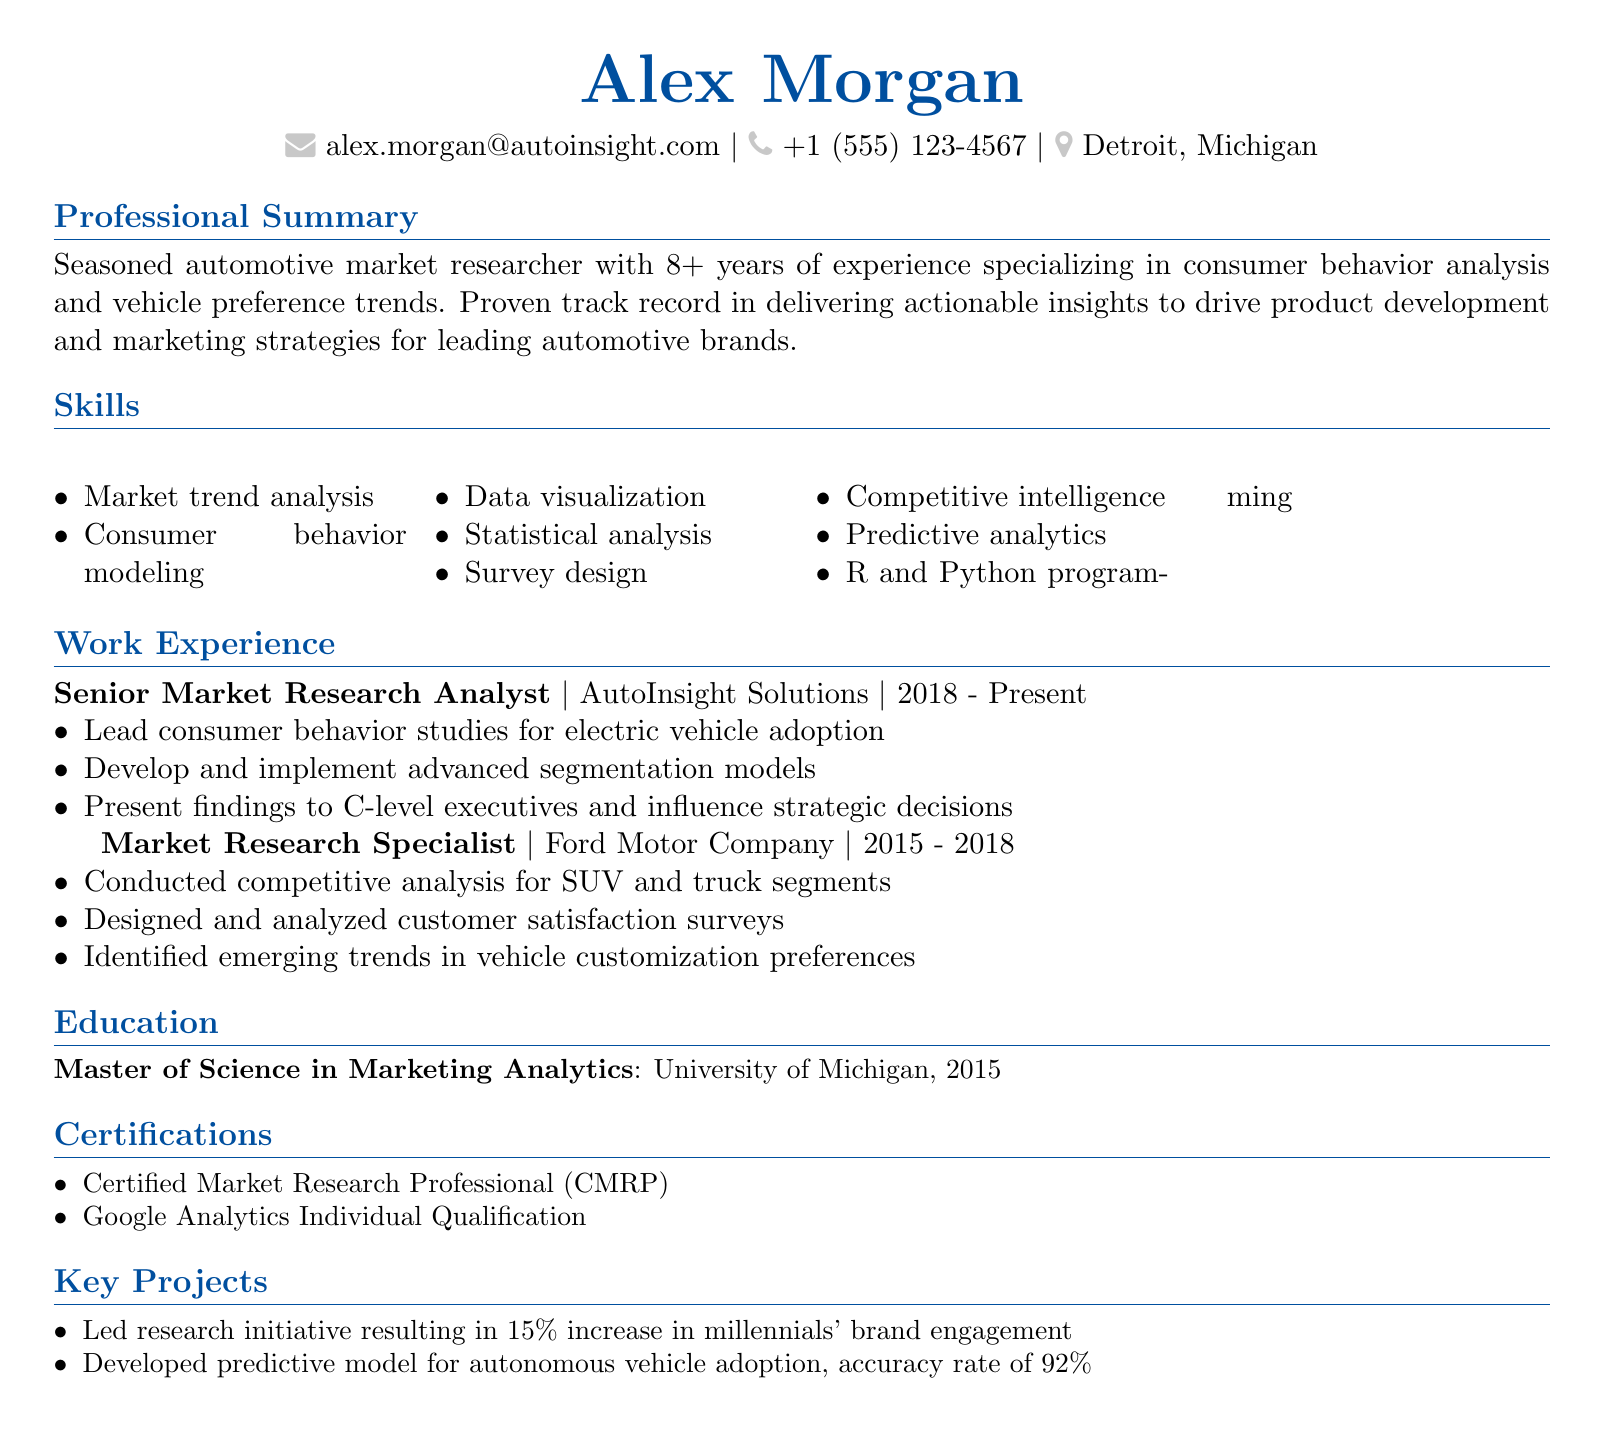what is the name of the candidate? The name of the candidate is provided at the top of the document.
Answer: Alex Morgan what is the candidate's email address? The email address is displayed in the personal information section.
Answer: alex.morgan@autoinsight.com how many years of experience does the candidate have? The candidate's experience is mentioned in the professional summary section.
Answer: 8+ which company did the candidate work for from 2015 to 2018? This information is found in the work experience section.
Answer: Ford Motor Company what is the highest degree obtained by the candidate? The education section provides details about the candidate's highest qualification.
Answer: Master of Science in Marketing Analytics what certification does the candidate hold related to market research? The certifications section lists the candidate's relevant qualifications.
Answer: Certified Market Research Professional (CMRP) which skill focuses on analyzing market trends? The skills section lists various expertise areas of the candidate.
Answer: Market trend analysis how accurate was the candidate’s predictive model for autonomous vehicle adoption? This is mentioned in the key projects section of the document.
Answer: 92% what was a result of the research initiative led by the candidate? A specific outcome of a key project is highlighted.
Answer: 15% increase in millennials' brand engagement 